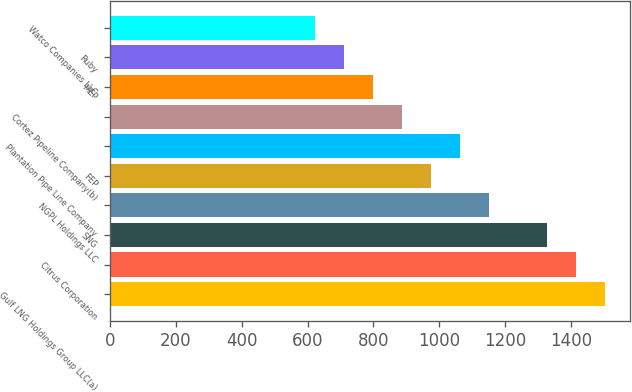Convert chart to OTSL. <chart><loc_0><loc_0><loc_500><loc_500><bar_chart><fcel>Gulf LNG Holdings Group LLC(a)<fcel>Citrus Corporation<fcel>SNG<fcel>NGPL Holdings LLC<fcel>FEP<fcel>Plantation Pipe Line Company<fcel>Cortez Pipeline Company(b)<fcel>MEP<fcel>Ruby<fcel>Watco Companies LLC<nl><fcel>1505.1<fcel>1416.8<fcel>1328.5<fcel>1151.9<fcel>975.3<fcel>1063.6<fcel>887<fcel>798.7<fcel>710.4<fcel>622.1<nl></chart> 